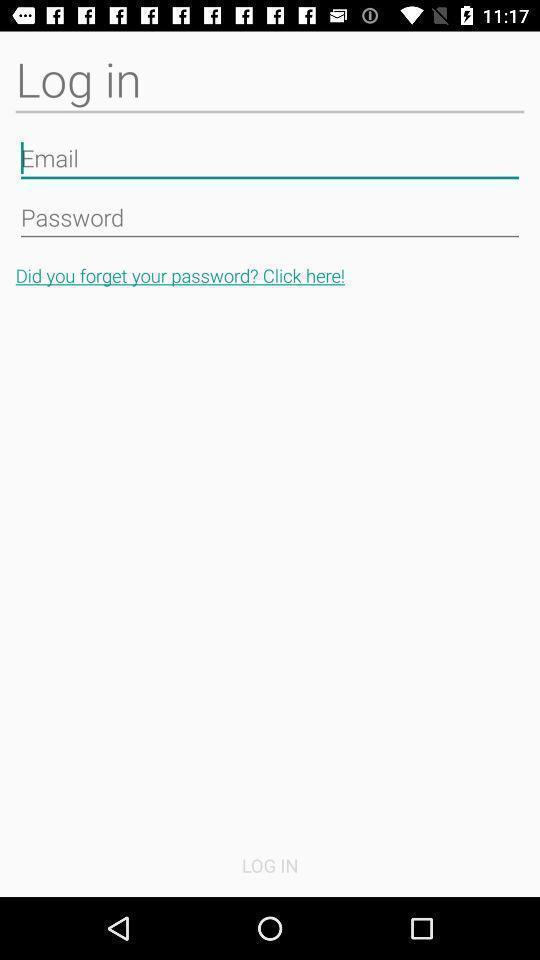Provide a textual representation of this image. Screen showing login page. 